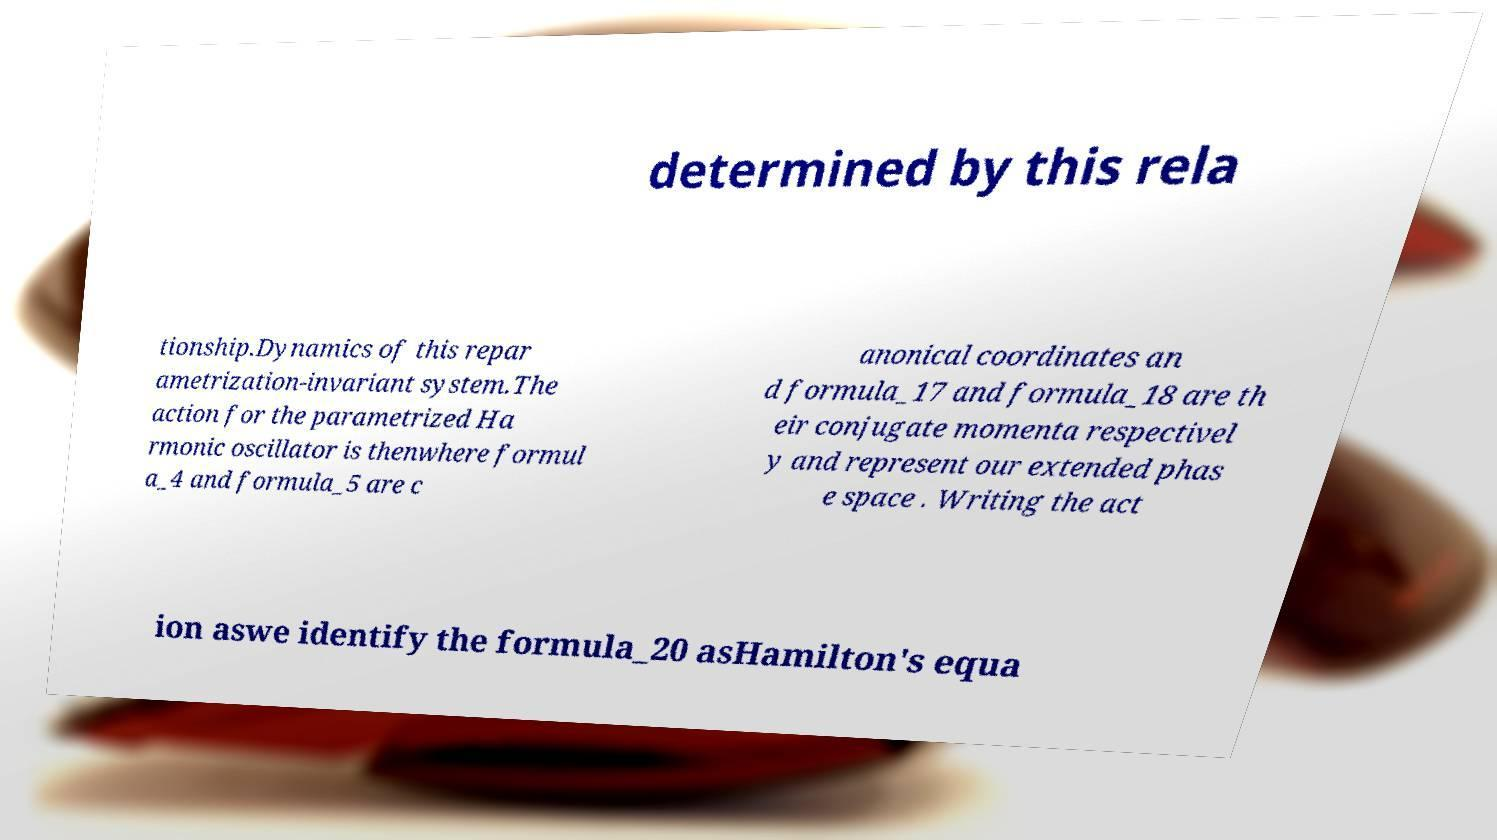For documentation purposes, I need the text within this image transcribed. Could you provide that? determined by this rela tionship.Dynamics of this repar ametrization-invariant system.The action for the parametrized Ha rmonic oscillator is thenwhere formul a_4 and formula_5 are c anonical coordinates an d formula_17 and formula_18 are th eir conjugate momenta respectivel y and represent our extended phas e space . Writing the act ion aswe identify the formula_20 asHamilton's equa 